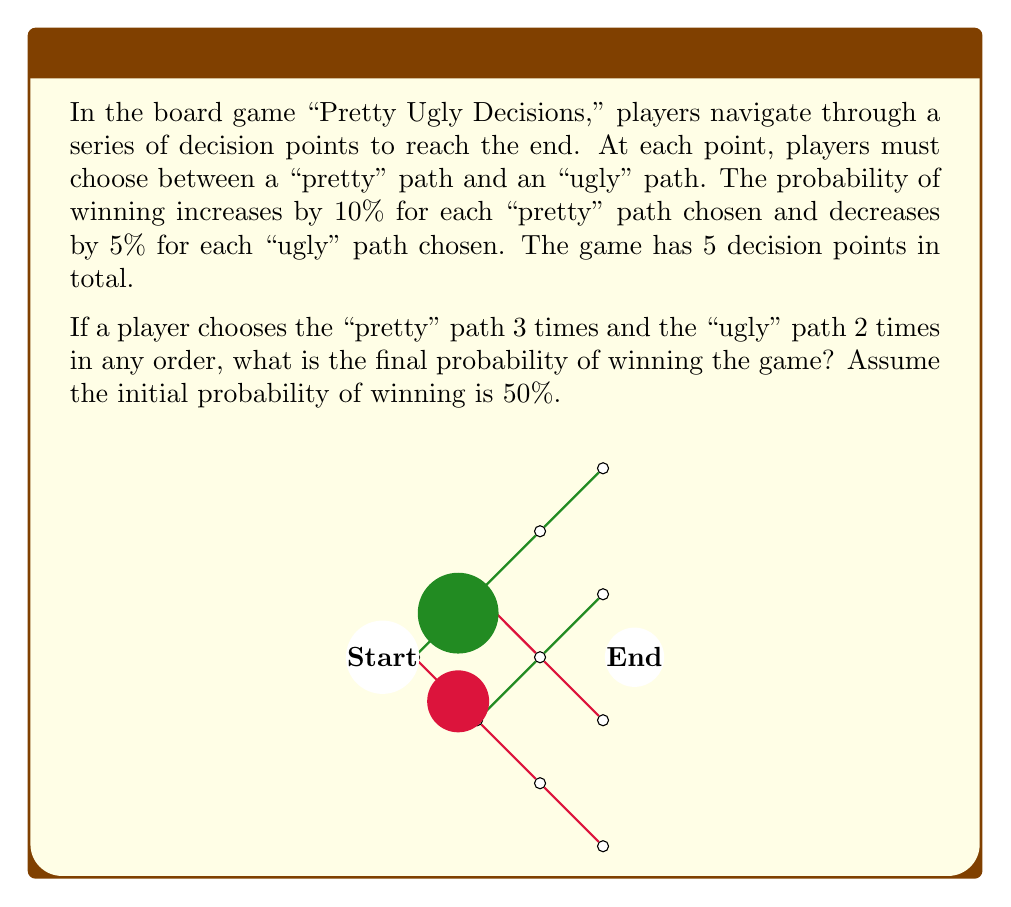Provide a solution to this math problem. Let's approach this step-by-step:

1) The initial probability of winning is 50% or 0.5.

2) For each "pretty" path chosen, the probability increases by 10% (0.1):
   $$ \text{Pretty path effect} = 0.1 \times 3 = 0.3 $$

3) For each "ugly" path chosen, the probability decreases by 5% (0.05):
   $$ \text{Ugly path effect} = 0.05 \times 2 = 0.1 $$

4) The net effect on the probability is:
   $$ \text{Net effect} = 0.3 - 0.1 = 0.2 $$

5) To calculate the final probability, we add the net effect to the initial probability:
   $$ \text{Final probability} = 0.5 + 0.2 = 0.7 $$

6) Convert the decimal to a percentage:
   $$ 0.7 \times 100\% = 70\% $$

Therefore, the final probability of winning the game is 70%.
Answer: 70% 